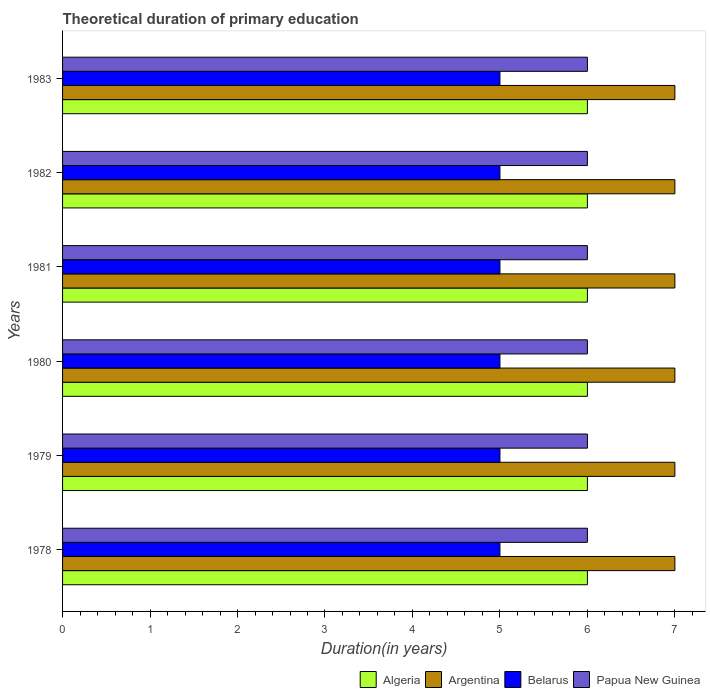How many different coloured bars are there?
Your answer should be very brief. 4. How many groups of bars are there?
Give a very brief answer. 6. Are the number of bars per tick equal to the number of legend labels?
Offer a terse response. Yes. Are the number of bars on each tick of the Y-axis equal?
Give a very brief answer. Yes. How many bars are there on the 4th tick from the top?
Offer a terse response. 4. What is the label of the 2nd group of bars from the top?
Offer a very short reply. 1982. In how many cases, is the number of bars for a given year not equal to the number of legend labels?
Keep it short and to the point. 0. Across all years, what is the maximum total theoretical duration of primary education in Belarus?
Make the answer very short. 5. Across all years, what is the minimum total theoretical duration of primary education in Argentina?
Give a very brief answer. 7. In which year was the total theoretical duration of primary education in Algeria maximum?
Your answer should be compact. 1978. In which year was the total theoretical duration of primary education in Argentina minimum?
Offer a very short reply. 1978. What is the total total theoretical duration of primary education in Argentina in the graph?
Make the answer very short. 42. What is the difference between the total theoretical duration of primary education in Papua New Guinea in 1979 and that in 1982?
Keep it short and to the point. 0. What is the difference between the total theoretical duration of primary education in Belarus in 1978 and the total theoretical duration of primary education in Papua New Guinea in 1983?
Provide a short and direct response. -1. In the year 1981, what is the difference between the total theoretical duration of primary education in Algeria and total theoretical duration of primary education in Argentina?
Keep it short and to the point. -1. What is the ratio of the total theoretical duration of primary education in Algeria in 1980 to that in 1982?
Keep it short and to the point. 1. Is the difference between the total theoretical duration of primary education in Algeria in 1979 and 1980 greater than the difference between the total theoretical duration of primary education in Argentina in 1979 and 1980?
Offer a very short reply. No. In how many years, is the total theoretical duration of primary education in Argentina greater than the average total theoretical duration of primary education in Argentina taken over all years?
Your answer should be very brief. 0. Is the sum of the total theoretical duration of primary education in Algeria in 1981 and 1983 greater than the maximum total theoretical duration of primary education in Belarus across all years?
Offer a very short reply. Yes. Is it the case that in every year, the sum of the total theoretical duration of primary education in Belarus and total theoretical duration of primary education in Papua New Guinea is greater than the sum of total theoretical duration of primary education in Algeria and total theoretical duration of primary education in Argentina?
Provide a succinct answer. No. What does the 4th bar from the top in 1979 represents?
Your response must be concise. Algeria. What does the 3rd bar from the bottom in 1983 represents?
Your answer should be compact. Belarus. Are all the bars in the graph horizontal?
Offer a very short reply. Yes. How are the legend labels stacked?
Ensure brevity in your answer.  Horizontal. What is the title of the graph?
Offer a very short reply. Theoretical duration of primary education. Does "Greenland" appear as one of the legend labels in the graph?
Your response must be concise. No. What is the label or title of the X-axis?
Offer a very short reply. Duration(in years). What is the label or title of the Y-axis?
Keep it short and to the point. Years. What is the Duration(in years) of Papua New Guinea in 1978?
Provide a succinct answer. 6. What is the Duration(in years) in Algeria in 1979?
Your answer should be compact. 6. What is the Duration(in years) in Argentina in 1980?
Provide a succinct answer. 7. What is the Duration(in years) in Papua New Guinea in 1980?
Your answer should be compact. 6. What is the Duration(in years) of Algeria in 1981?
Keep it short and to the point. 6. What is the Duration(in years) of Belarus in 1981?
Your answer should be compact. 5. What is the Duration(in years) in Algeria in 1982?
Give a very brief answer. 6. What is the Duration(in years) of Argentina in 1982?
Your answer should be compact. 7. What is the Duration(in years) in Belarus in 1982?
Keep it short and to the point. 5. What is the Duration(in years) of Algeria in 1983?
Keep it short and to the point. 6. What is the Duration(in years) of Argentina in 1983?
Offer a terse response. 7. Across all years, what is the minimum Duration(in years) of Argentina?
Make the answer very short. 7. Across all years, what is the minimum Duration(in years) of Belarus?
Give a very brief answer. 5. What is the total Duration(in years) of Algeria in the graph?
Ensure brevity in your answer.  36. What is the total Duration(in years) in Argentina in the graph?
Ensure brevity in your answer.  42. What is the difference between the Duration(in years) in Algeria in 1978 and that in 1979?
Your response must be concise. 0. What is the difference between the Duration(in years) of Belarus in 1978 and that in 1979?
Provide a succinct answer. 0. What is the difference between the Duration(in years) of Belarus in 1978 and that in 1980?
Make the answer very short. 0. What is the difference between the Duration(in years) of Papua New Guinea in 1978 and that in 1980?
Provide a short and direct response. 0. What is the difference between the Duration(in years) in Papua New Guinea in 1978 and that in 1981?
Make the answer very short. 0. What is the difference between the Duration(in years) in Argentina in 1978 and that in 1982?
Offer a terse response. 0. What is the difference between the Duration(in years) of Belarus in 1978 and that in 1982?
Your answer should be compact. 0. What is the difference between the Duration(in years) of Papua New Guinea in 1978 and that in 1982?
Your response must be concise. 0. What is the difference between the Duration(in years) in Argentina in 1978 and that in 1983?
Offer a very short reply. 0. What is the difference between the Duration(in years) of Belarus in 1978 and that in 1983?
Provide a succinct answer. 0. What is the difference between the Duration(in years) in Papua New Guinea in 1979 and that in 1980?
Make the answer very short. 0. What is the difference between the Duration(in years) of Algeria in 1979 and that in 1981?
Your response must be concise. 0. What is the difference between the Duration(in years) in Argentina in 1979 and that in 1981?
Offer a terse response. 0. What is the difference between the Duration(in years) in Belarus in 1979 and that in 1981?
Give a very brief answer. 0. What is the difference between the Duration(in years) of Belarus in 1979 and that in 1982?
Your answer should be compact. 0. What is the difference between the Duration(in years) of Papua New Guinea in 1979 and that in 1982?
Provide a succinct answer. 0. What is the difference between the Duration(in years) in Papua New Guinea in 1979 and that in 1983?
Provide a succinct answer. 0. What is the difference between the Duration(in years) in Algeria in 1980 and that in 1981?
Provide a short and direct response. 0. What is the difference between the Duration(in years) in Papua New Guinea in 1980 and that in 1981?
Provide a short and direct response. 0. What is the difference between the Duration(in years) in Belarus in 1980 and that in 1982?
Your answer should be very brief. 0. What is the difference between the Duration(in years) of Algeria in 1980 and that in 1983?
Your answer should be very brief. 0. What is the difference between the Duration(in years) in Argentina in 1980 and that in 1983?
Offer a very short reply. 0. What is the difference between the Duration(in years) of Belarus in 1980 and that in 1983?
Keep it short and to the point. 0. What is the difference between the Duration(in years) of Algeria in 1981 and that in 1982?
Your answer should be very brief. 0. What is the difference between the Duration(in years) in Algeria in 1981 and that in 1983?
Provide a short and direct response. 0. What is the difference between the Duration(in years) in Papua New Guinea in 1981 and that in 1983?
Provide a short and direct response. 0. What is the difference between the Duration(in years) in Argentina in 1982 and that in 1983?
Provide a succinct answer. 0. What is the difference between the Duration(in years) of Algeria in 1978 and the Duration(in years) of Argentina in 1979?
Give a very brief answer. -1. What is the difference between the Duration(in years) of Algeria in 1978 and the Duration(in years) of Papua New Guinea in 1979?
Give a very brief answer. 0. What is the difference between the Duration(in years) of Argentina in 1978 and the Duration(in years) of Belarus in 1979?
Give a very brief answer. 2. What is the difference between the Duration(in years) of Argentina in 1978 and the Duration(in years) of Papua New Guinea in 1979?
Make the answer very short. 1. What is the difference between the Duration(in years) in Algeria in 1978 and the Duration(in years) in Argentina in 1980?
Offer a terse response. -1. What is the difference between the Duration(in years) of Argentina in 1978 and the Duration(in years) of Belarus in 1980?
Your answer should be compact. 2. What is the difference between the Duration(in years) in Argentina in 1978 and the Duration(in years) in Papua New Guinea in 1980?
Offer a terse response. 1. What is the difference between the Duration(in years) of Belarus in 1978 and the Duration(in years) of Papua New Guinea in 1980?
Make the answer very short. -1. What is the difference between the Duration(in years) of Algeria in 1978 and the Duration(in years) of Belarus in 1981?
Your answer should be compact. 1. What is the difference between the Duration(in years) in Algeria in 1978 and the Duration(in years) in Papua New Guinea in 1981?
Your answer should be compact. 0. What is the difference between the Duration(in years) in Belarus in 1978 and the Duration(in years) in Papua New Guinea in 1981?
Keep it short and to the point. -1. What is the difference between the Duration(in years) in Algeria in 1978 and the Duration(in years) in Argentina in 1982?
Offer a very short reply. -1. What is the difference between the Duration(in years) in Algeria in 1978 and the Duration(in years) in Belarus in 1982?
Offer a terse response. 1. What is the difference between the Duration(in years) of Argentina in 1978 and the Duration(in years) of Belarus in 1982?
Ensure brevity in your answer.  2. What is the difference between the Duration(in years) of Belarus in 1978 and the Duration(in years) of Papua New Guinea in 1982?
Provide a short and direct response. -1. What is the difference between the Duration(in years) in Algeria in 1978 and the Duration(in years) in Argentina in 1983?
Your answer should be very brief. -1. What is the difference between the Duration(in years) of Algeria in 1978 and the Duration(in years) of Belarus in 1983?
Your answer should be very brief. 1. What is the difference between the Duration(in years) in Argentina in 1978 and the Duration(in years) in Belarus in 1983?
Ensure brevity in your answer.  2. What is the difference between the Duration(in years) in Argentina in 1978 and the Duration(in years) in Papua New Guinea in 1983?
Your response must be concise. 1. What is the difference between the Duration(in years) of Belarus in 1978 and the Duration(in years) of Papua New Guinea in 1983?
Your response must be concise. -1. What is the difference between the Duration(in years) in Algeria in 1979 and the Duration(in years) in Argentina in 1980?
Your response must be concise. -1. What is the difference between the Duration(in years) of Belarus in 1979 and the Duration(in years) of Papua New Guinea in 1980?
Provide a succinct answer. -1. What is the difference between the Duration(in years) in Argentina in 1979 and the Duration(in years) in Belarus in 1981?
Keep it short and to the point. 2. What is the difference between the Duration(in years) of Argentina in 1979 and the Duration(in years) of Papua New Guinea in 1981?
Ensure brevity in your answer.  1. What is the difference between the Duration(in years) of Belarus in 1979 and the Duration(in years) of Papua New Guinea in 1981?
Make the answer very short. -1. What is the difference between the Duration(in years) of Algeria in 1979 and the Duration(in years) of Argentina in 1982?
Offer a terse response. -1. What is the difference between the Duration(in years) of Algeria in 1979 and the Duration(in years) of Papua New Guinea in 1982?
Ensure brevity in your answer.  0. What is the difference between the Duration(in years) of Algeria in 1979 and the Duration(in years) of Argentina in 1983?
Your response must be concise. -1. What is the difference between the Duration(in years) of Belarus in 1979 and the Duration(in years) of Papua New Guinea in 1983?
Offer a terse response. -1. What is the difference between the Duration(in years) in Algeria in 1980 and the Duration(in years) in Argentina in 1981?
Keep it short and to the point. -1. What is the difference between the Duration(in years) in Algeria in 1980 and the Duration(in years) in Belarus in 1981?
Your response must be concise. 1. What is the difference between the Duration(in years) of Argentina in 1980 and the Duration(in years) of Papua New Guinea in 1981?
Your answer should be very brief. 1. What is the difference between the Duration(in years) in Algeria in 1980 and the Duration(in years) in Argentina in 1982?
Your answer should be very brief. -1. What is the difference between the Duration(in years) of Algeria in 1980 and the Duration(in years) of Papua New Guinea in 1982?
Your answer should be very brief. 0. What is the difference between the Duration(in years) of Argentina in 1980 and the Duration(in years) of Belarus in 1982?
Offer a terse response. 2. What is the difference between the Duration(in years) in Algeria in 1980 and the Duration(in years) in Argentina in 1983?
Your answer should be very brief. -1. What is the difference between the Duration(in years) in Algeria in 1980 and the Duration(in years) in Papua New Guinea in 1983?
Ensure brevity in your answer.  0. What is the difference between the Duration(in years) of Argentina in 1980 and the Duration(in years) of Papua New Guinea in 1983?
Make the answer very short. 1. What is the difference between the Duration(in years) in Algeria in 1981 and the Duration(in years) in Belarus in 1982?
Keep it short and to the point. 1. What is the difference between the Duration(in years) of Algeria in 1981 and the Duration(in years) of Papua New Guinea in 1982?
Offer a terse response. 0. What is the difference between the Duration(in years) in Argentina in 1981 and the Duration(in years) in Belarus in 1982?
Provide a short and direct response. 2. What is the difference between the Duration(in years) in Belarus in 1981 and the Duration(in years) in Papua New Guinea in 1982?
Make the answer very short. -1. What is the difference between the Duration(in years) in Argentina in 1981 and the Duration(in years) in Belarus in 1983?
Your answer should be compact. 2. What is the difference between the Duration(in years) in Algeria in 1982 and the Duration(in years) in Argentina in 1983?
Offer a terse response. -1. What is the difference between the Duration(in years) in Algeria in 1982 and the Duration(in years) in Belarus in 1983?
Your answer should be very brief. 1. What is the difference between the Duration(in years) in Algeria in 1982 and the Duration(in years) in Papua New Guinea in 1983?
Keep it short and to the point. 0. What is the difference between the Duration(in years) of Argentina in 1982 and the Duration(in years) of Papua New Guinea in 1983?
Make the answer very short. 1. What is the average Duration(in years) of Algeria per year?
Your answer should be compact. 6. What is the average Duration(in years) of Argentina per year?
Make the answer very short. 7. What is the average Duration(in years) in Belarus per year?
Provide a succinct answer. 5. In the year 1978, what is the difference between the Duration(in years) of Algeria and Duration(in years) of Argentina?
Your response must be concise. -1. In the year 1978, what is the difference between the Duration(in years) in Argentina and Duration(in years) in Papua New Guinea?
Your answer should be very brief. 1. In the year 1979, what is the difference between the Duration(in years) in Algeria and Duration(in years) in Papua New Guinea?
Make the answer very short. 0. In the year 1979, what is the difference between the Duration(in years) of Argentina and Duration(in years) of Belarus?
Offer a terse response. 2. In the year 1979, what is the difference between the Duration(in years) of Argentina and Duration(in years) of Papua New Guinea?
Keep it short and to the point. 1. In the year 1980, what is the difference between the Duration(in years) in Algeria and Duration(in years) in Belarus?
Offer a very short reply. 1. In the year 1980, what is the difference between the Duration(in years) of Argentina and Duration(in years) of Belarus?
Your response must be concise. 2. In the year 1980, what is the difference between the Duration(in years) in Belarus and Duration(in years) in Papua New Guinea?
Provide a short and direct response. -1. In the year 1981, what is the difference between the Duration(in years) in Algeria and Duration(in years) in Argentina?
Offer a very short reply. -1. In the year 1981, what is the difference between the Duration(in years) of Algeria and Duration(in years) of Papua New Guinea?
Your answer should be very brief. 0. In the year 1981, what is the difference between the Duration(in years) in Belarus and Duration(in years) in Papua New Guinea?
Give a very brief answer. -1. In the year 1982, what is the difference between the Duration(in years) of Argentina and Duration(in years) of Papua New Guinea?
Offer a very short reply. 1. In the year 1982, what is the difference between the Duration(in years) of Belarus and Duration(in years) of Papua New Guinea?
Your response must be concise. -1. In the year 1983, what is the difference between the Duration(in years) in Algeria and Duration(in years) in Argentina?
Your answer should be very brief. -1. In the year 1983, what is the difference between the Duration(in years) of Algeria and Duration(in years) of Belarus?
Offer a very short reply. 1. In the year 1983, what is the difference between the Duration(in years) in Algeria and Duration(in years) in Papua New Guinea?
Give a very brief answer. 0. In the year 1983, what is the difference between the Duration(in years) of Argentina and Duration(in years) of Papua New Guinea?
Provide a succinct answer. 1. In the year 1983, what is the difference between the Duration(in years) in Belarus and Duration(in years) in Papua New Guinea?
Ensure brevity in your answer.  -1. What is the ratio of the Duration(in years) of Algeria in 1978 to that in 1979?
Keep it short and to the point. 1. What is the ratio of the Duration(in years) of Argentina in 1978 to that in 1979?
Make the answer very short. 1. What is the ratio of the Duration(in years) of Algeria in 1978 to that in 1980?
Your response must be concise. 1. What is the ratio of the Duration(in years) in Belarus in 1978 to that in 1980?
Your response must be concise. 1. What is the ratio of the Duration(in years) in Papua New Guinea in 1978 to that in 1980?
Your answer should be compact. 1. What is the ratio of the Duration(in years) of Algeria in 1978 to that in 1981?
Keep it short and to the point. 1. What is the ratio of the Duration(in years) of Argentina in 1978 to that in 1981?
Provide a short and direct response. 1. What is the ratio of the Duration(in years) in Belarus in 1978 to that in 1981?
Make the answer very short. 1. What is the ratio of the Duration(in years) in Papua New Guinea in 1978 to that in 1981?
Your response must be concise. 1. What is the ratio of the Duration(in years) in Algeria in 1978 to that in 1982?
Offer a very short reply. 1. What is the ratio of the Duration(in years) of Belarus in 1978 to that in 1982?
Ensure brevity in your answer.  1. What is the ratio of the Duration(in years) of Papua New Guinea in 1978 to that in 1982?
Provide a short and direct response. 1. What is the ratio of the Duration(in years) in Algeria in 1978 to that in 1983?
Your answer should be compact. 1. What is the ratio of the Duration(in years) in Belarus in 1978 to that in 1983?
Ensure brevity in your answer.  1. What is the ratio of the Duration(in years) of Papua New Guinea in 1978 to that in 1983?
Your answer should be compact. 1. What is the ratio of the Duration(in years) in Algeria in 1979 to that in 1980?
Provide a short and direct response. 1. What is the ratio of the Duration(in years) in Belarus in 1979 to that in 1980?
Your answer should be compact. 1. What is the ratio of the Duration(in years) in Papua New Guinea in 1979 to that in 1981?
Give a very brief answer. 1. What is the ratio of the Duration(in years) in Algeria in 1979 to that in 1983?
Ensure brevity in your answer.  1. What is the ratio of the Duration(in years) of Argentina in 1979 to that in 1983?
Ensure brevity in your answer.  1. What is the ratio of the Duration(in years) of Belarus in 1979 to that in 1983?
Your response must be concise. 1. What is the ratio of the Duration(in years) in Algeria in 1980 to that in 1981?
Keep it short and to the point. 1. What is the ratio of the Duration(in years) of Belarus in 1980 to that in 1981?
Keep it short and to the point. 1. What is the ratio of the Duration(in years) of Algeria in 1980 to that in 1982?
Offer a very short reply. 1. What is the ratio of the Duration(in years) in Belarus in 1980 to that in 1982?
Keep it short and to the point. 1. What is the ratio of the Duration(in years) of Papua New Guinea in 1980 to that in 1983?
Your answer should be very brief. 1. What is the ratio of the Duration(in years) in Algeria in 1981 to that in 1982?
Provide a short and direct response. 1. What is the ratio of the Duration(in years) in Belarus in 1981 to that in 1982?
Your response must be concise. 1. What is the ratio of the Duration(in years) of Papua New Guinea in 1981 to that in 1982?
Give a very brief answer. 1. What is the ratio of the Duration(in years) of Argentina in 1981 to that in 1983?
Keep it short and to the point. 1. What is the ratio of the Duration(in years) in Belarus in 1981 to that in 1983?
Keep it short and to the point. 1. What is the ratio of the Duration(in years) of Papua New Guinea in 1981 to that in 1983?
Give a very brief answer. 1. What is the ratio of the Duration(in years) in Algeria in 1982 to that in 1983?
Your answer should be very brief. 1. What is the ratio of the Duration(in years) of Belarus in 1982 to that in 1983?
Your answer should be compact. 1. What is the ratio of the Duration(in years) of Papua New Guinea in 1982 to that in 1983?
Your response must be concise. 1. What is the difference between the highest and the second highest Duration(in years) in Argentina?
Ensure brevity in your answer.  0. What is the difference between the highest and the second highest Duration(in years) in Papua New Guinea?
Your answer should be compact. 0. What is the difference between the highest and the lowest Duration(in years) of Algeria?
Your answer should be compact. 0. What is the difference between the highest and the lowest Duration(in years) in Argentina?
Make the answer very short. 0. What is the difference between the highest and the lowest Duration(in years) in Papua New Guinea?
Offer a terse response. 0. 